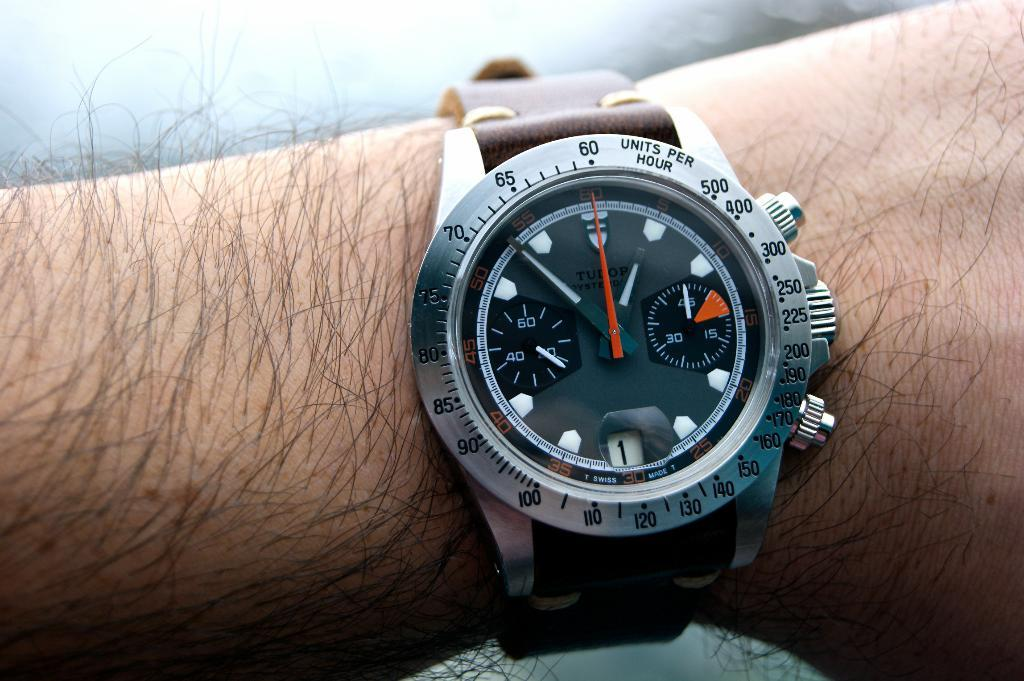Provide a one-sentence caption for the provided image. a man wearing a watch with the words Swiss Made at the bottom. 